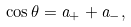Convert formula to latex. <formula><loc_0><loc_0><loc_500><loc_500>\cos \theta = a _ { + } + a _ { - } ,</formula> 